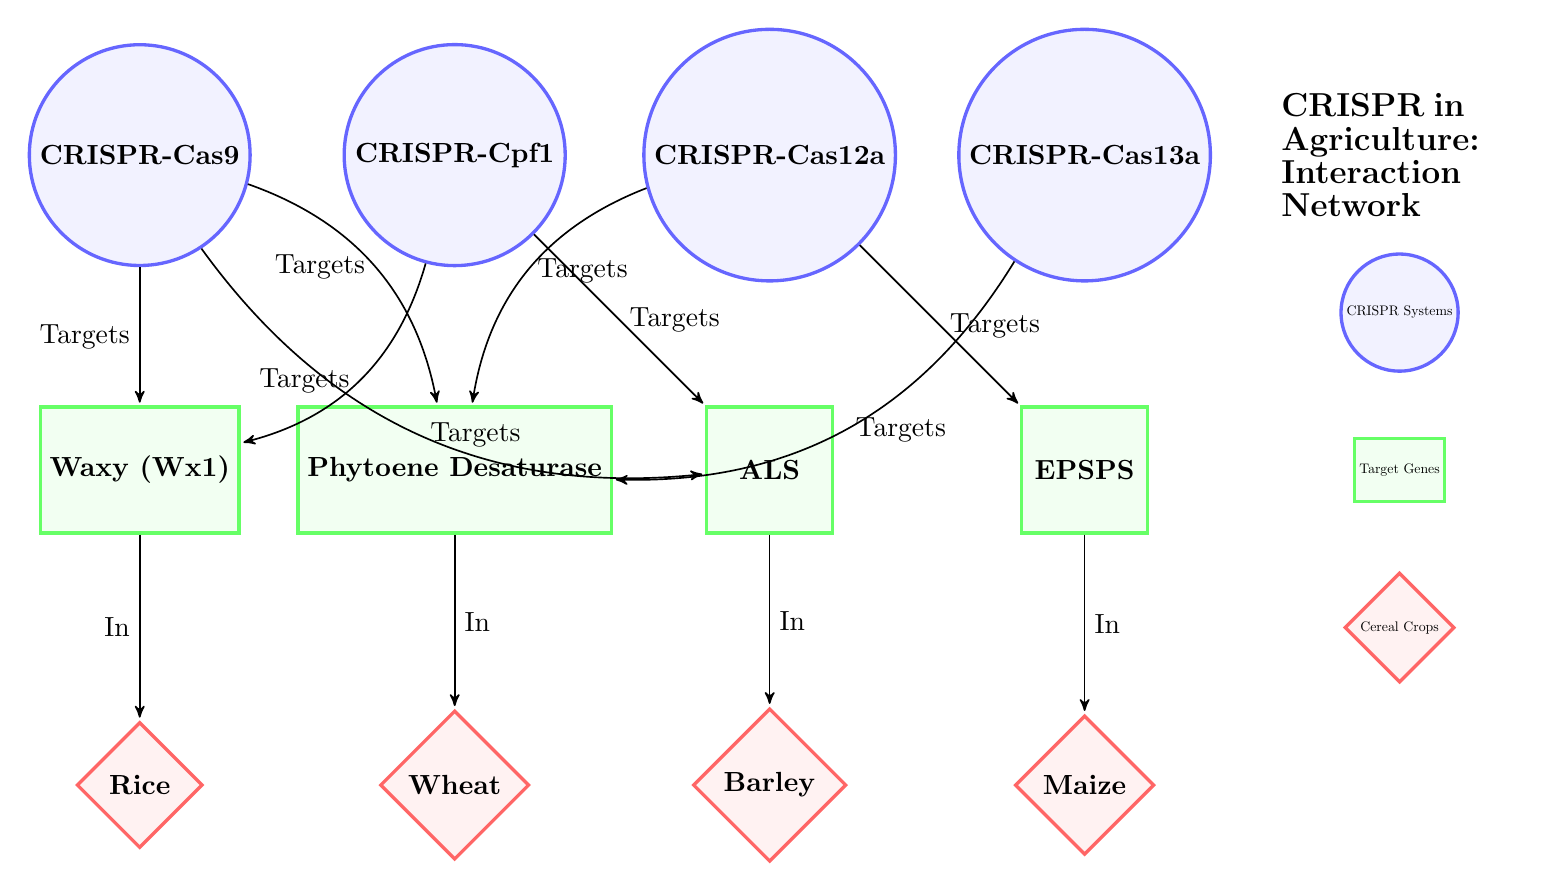What are the CRISPR systems depicted in the diagram? The diagram displays four CRISPR systems: CRISPR-Cas9, CRISPR-Cpf1, CRISPR-Cas12a, and CRISPR-Cas13a.
Answer: CRISPR-Cas9, CRISPR-Cpf1, CRISPR-Cas12a, CRISPR-Cas13a Which target gene is associated with CRISPR-Cas3? CRISPR-Cas3 is not mentioned in the diagram, so there is no associated target gene.
Answer: None How many target genes are illustrated in the diagram? The diagram shows four target genes: Waxy (Wx1), Phytoene Desaturase, ALS, and EPSPS.
Answer: Four Which CRISPR system targets the Gene EPSPS? According to the diagram, the CRISPR-Cas12a targets the Gene EPSPS.
Answer: CRISPR-Cas12a In which cereal crop is the gene Waxy (Wx1) present? The diagram specifies that the gene Waxy (Wx1) is present in Rice.
Answer: Rice Which two crops are linked to the target gene Phytoene Desaturase? The diagram indicates that Phytoene Desaturase is linked to Wheat and Maize.
Answer: Wheat and Maize What is the relationship between CRISPR-Cpf1 and Gene ALS? The diagram shows that CRISPR-Cpf1 does not have a direct edge to Gene ALS; instead, it connects to other genes.
Answer: None How many edges connect the CRISPR systems to different target genes? The diagram features a total of eight edges connecting various CRISPR systems to their corresponding target genes.
Answer: Eight Which CRISPR system is responsible for targeting the largest number of genes? The diagram indicates that CRISPR-Cas9 targets three genes, which is more than any other CRISPR system.
Answer: CRISPR-Cas9 